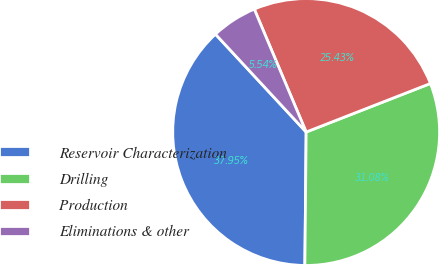Convert chart. <chart><loc_0><loc_0><loc_500><loc_500><pie_chart><fcel>Reservoir Characterization<fcel>Drilling<fcel>Production<fcel>Eliminations & other<nl><fcel>37.95%<fcel>31.08%<fcel>25.43%<fcel>5.54%<nl></chart> 